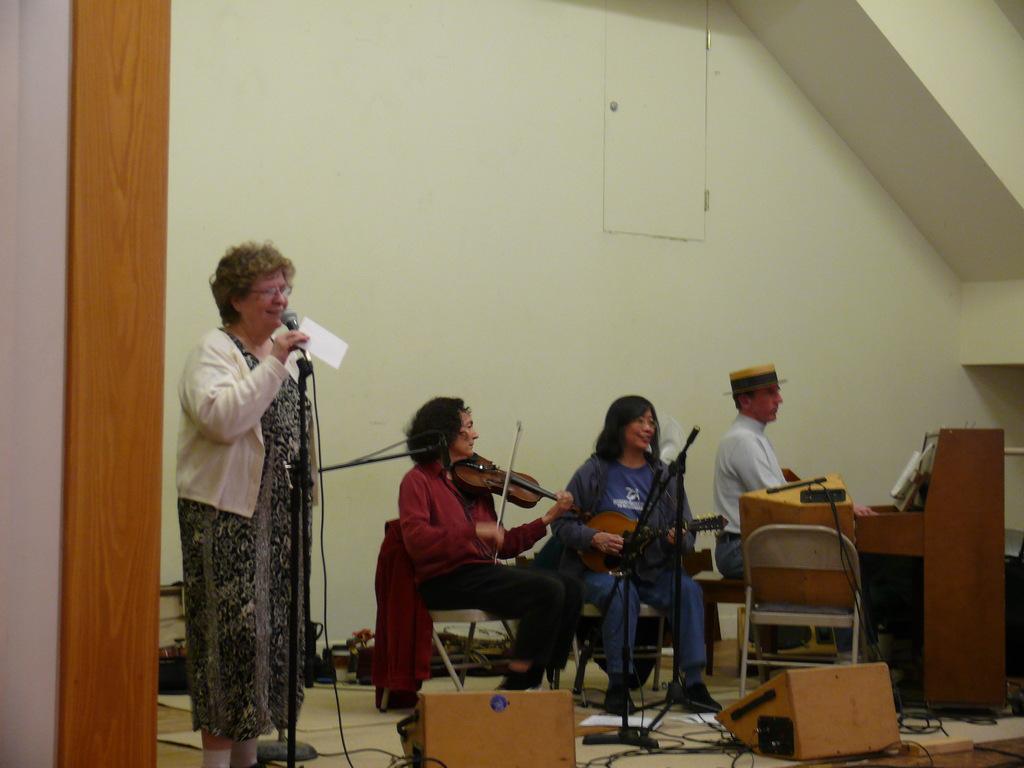Please provide a concise description of this image. In this picture there are two musicians on the chair playing guitar and a guy in the corner is playing a piano. To the left side of the image a lady is talking with a mic placed in her hands. In the background there are musical instruments , wires. There are also two brown boxes kept on the floor. 